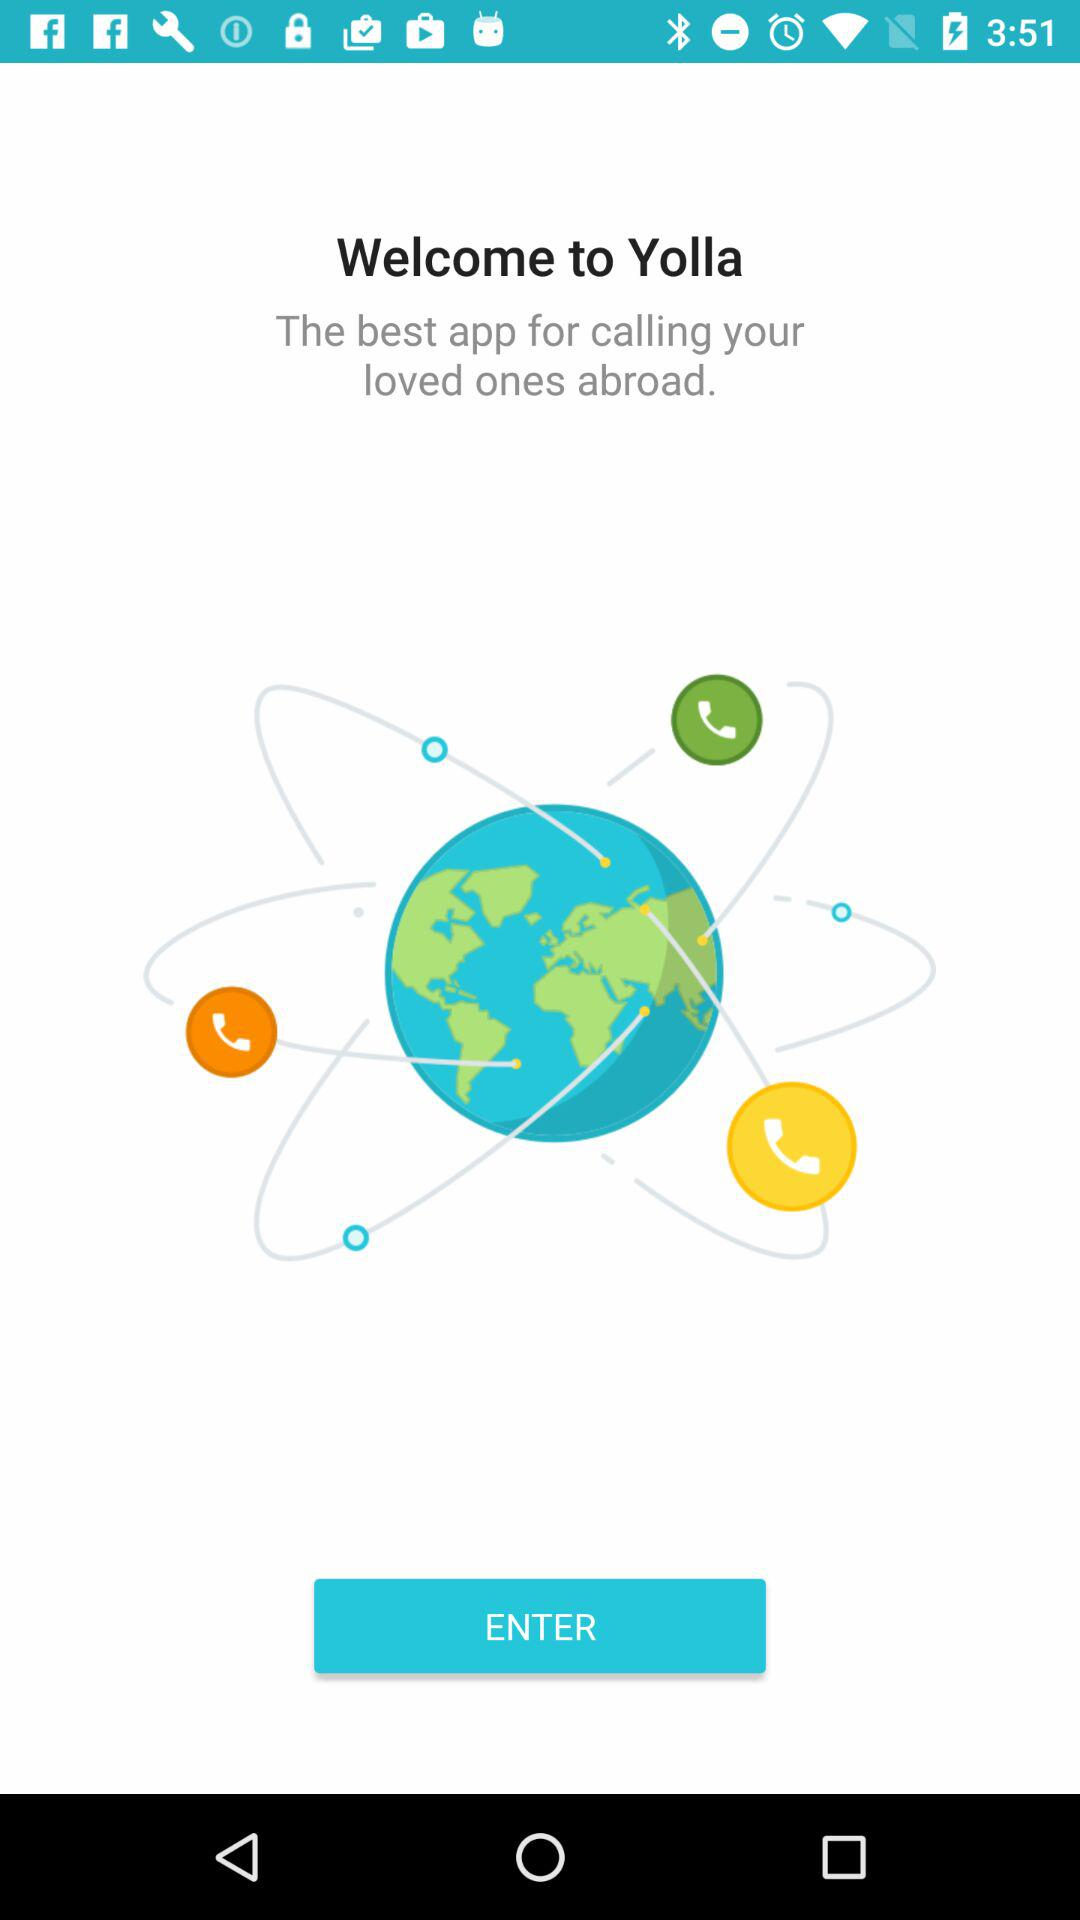What is the name of the application? The name of the application is "Yolla". 